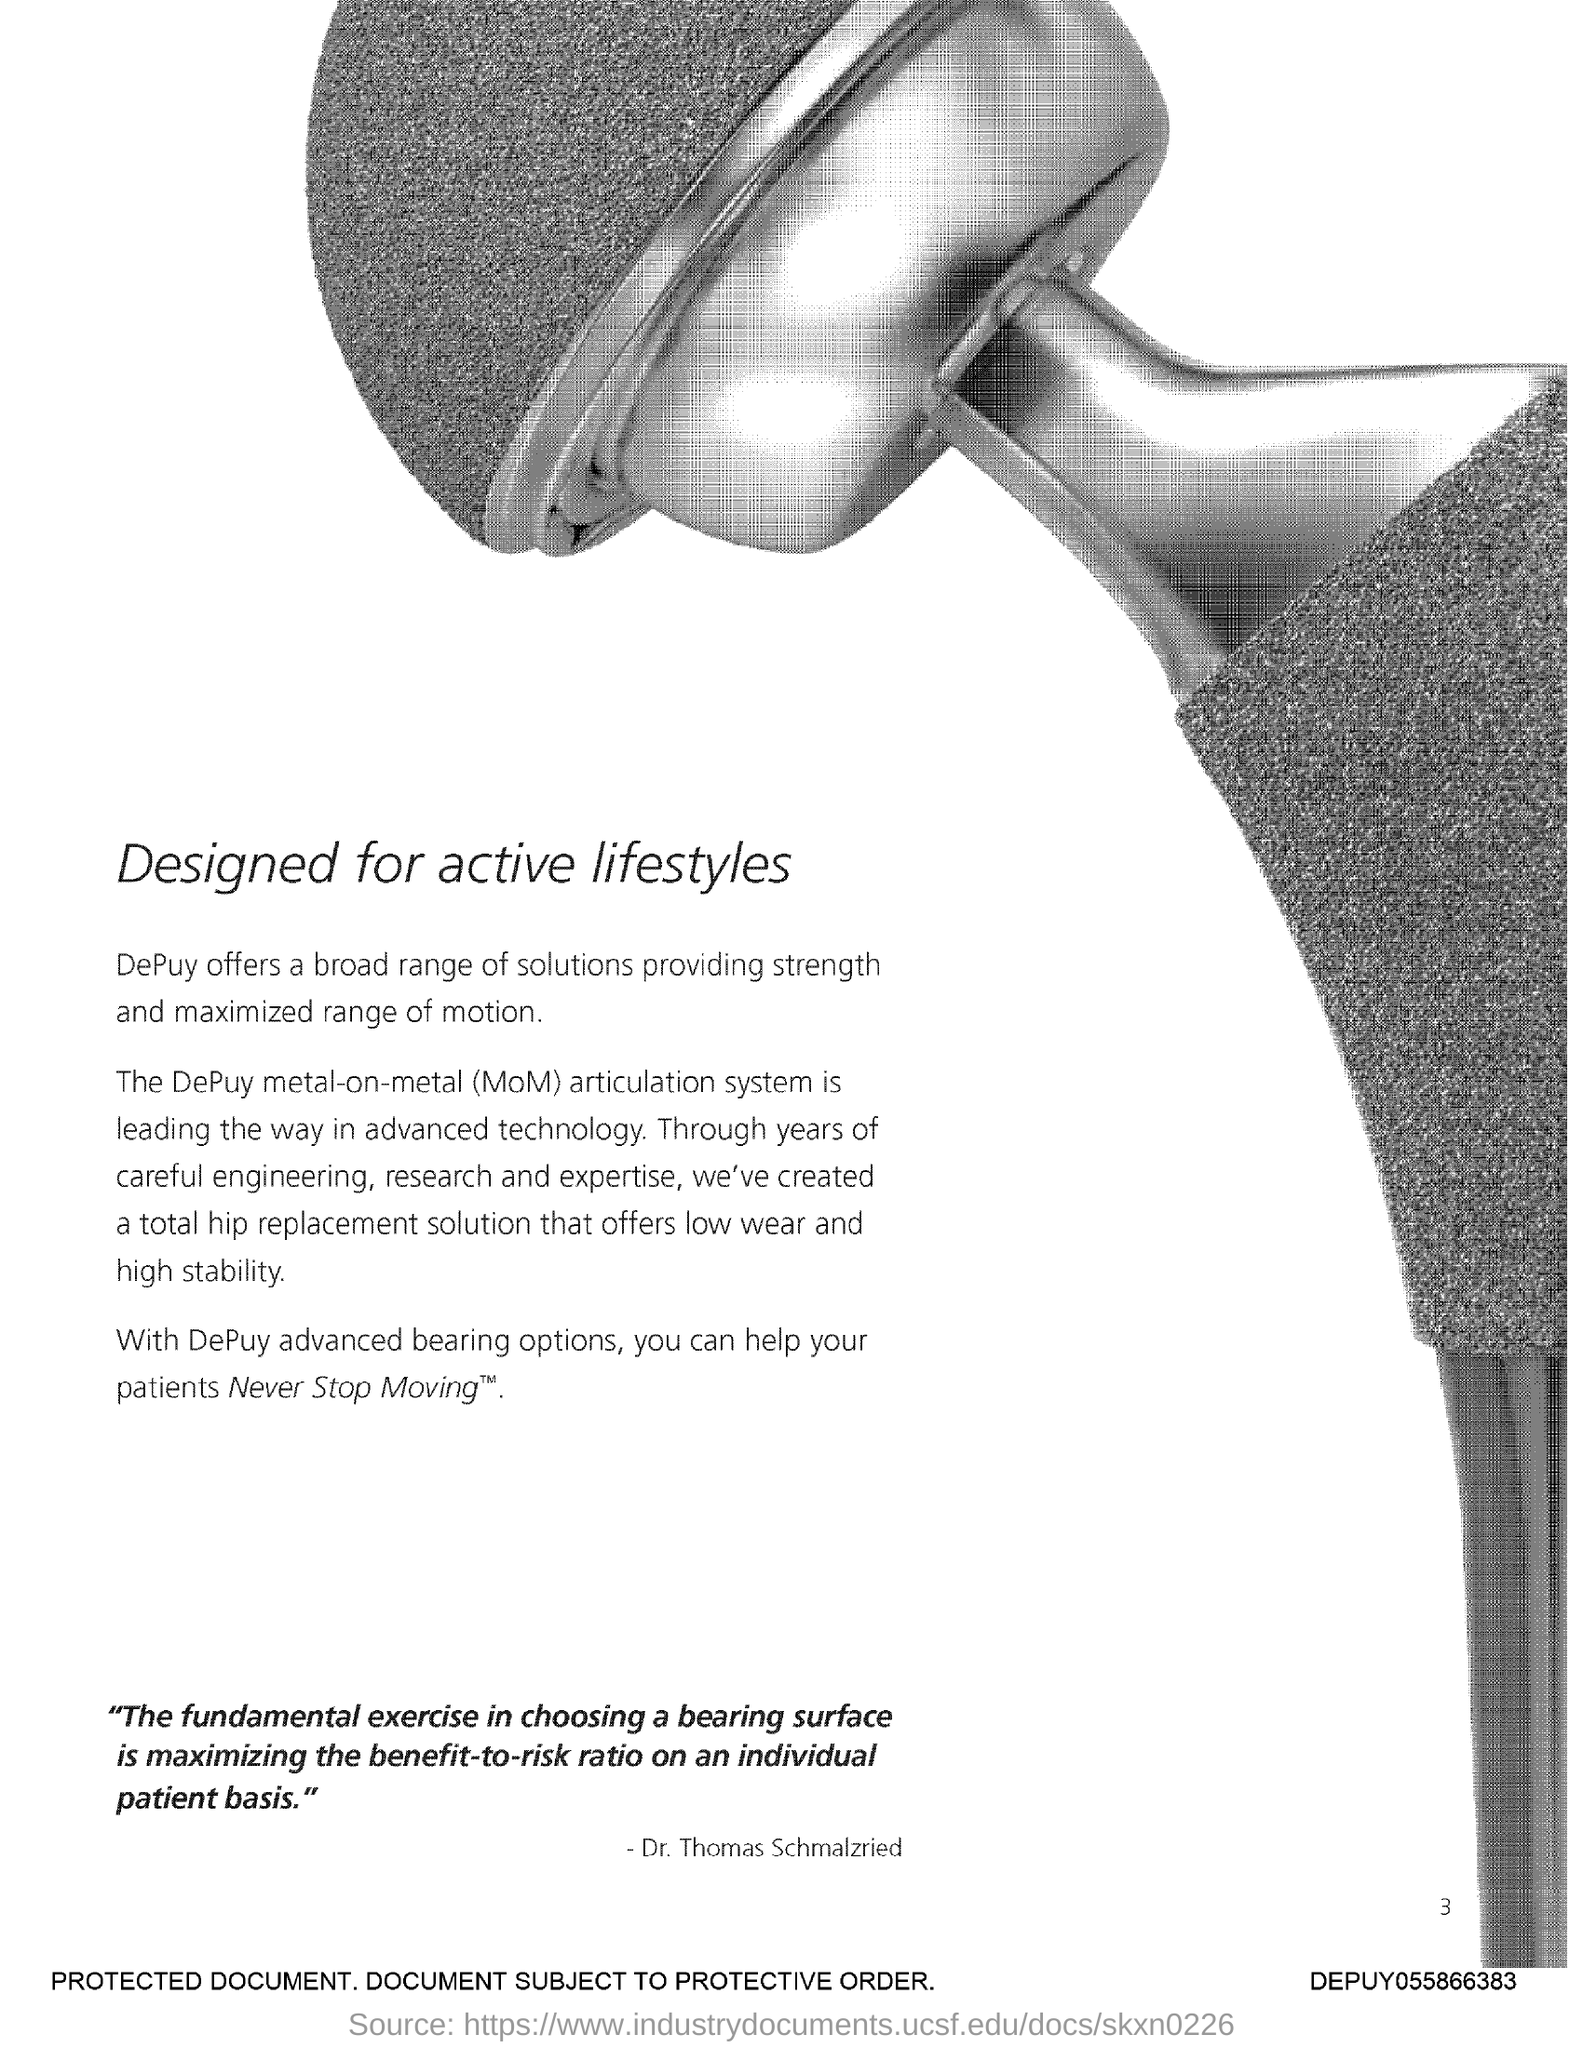Give some essential details in this illustration. The page number is 3. 